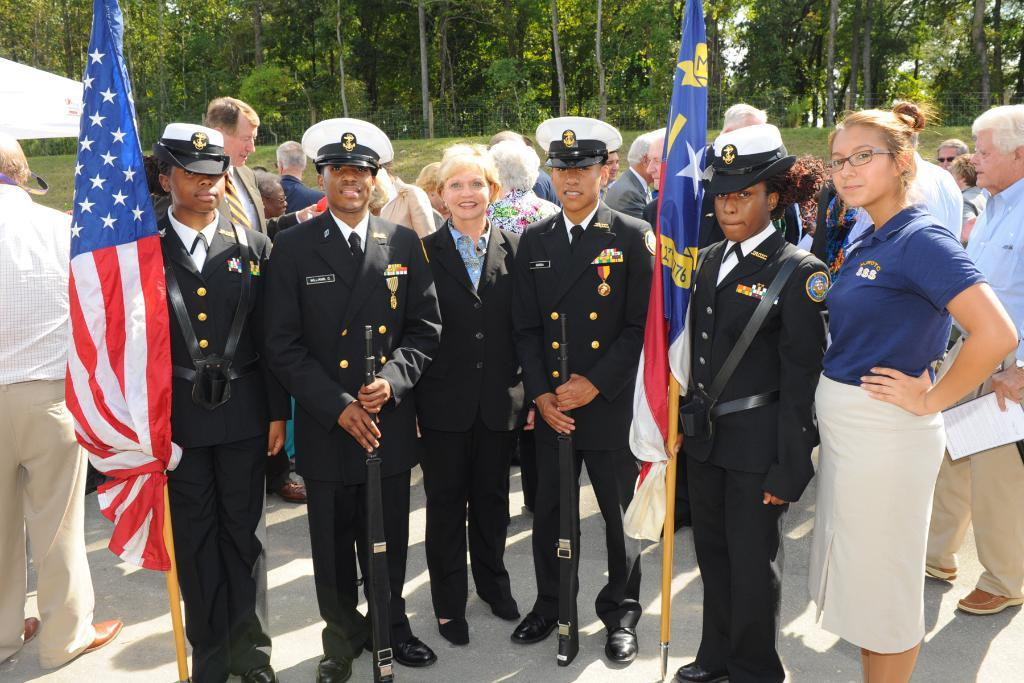What are the people in the image wearing? The people in the image are wearing uniforms. What are two of the people holding? Two persons are holding flags. Can you describe the background of the image? There are people visible in the background and trees in the background of the image. What type of attention is the person in the image giving to the clouds? There are no clouds present in the image, so it is not possible to determine what type of attention the person might be giving to them. 